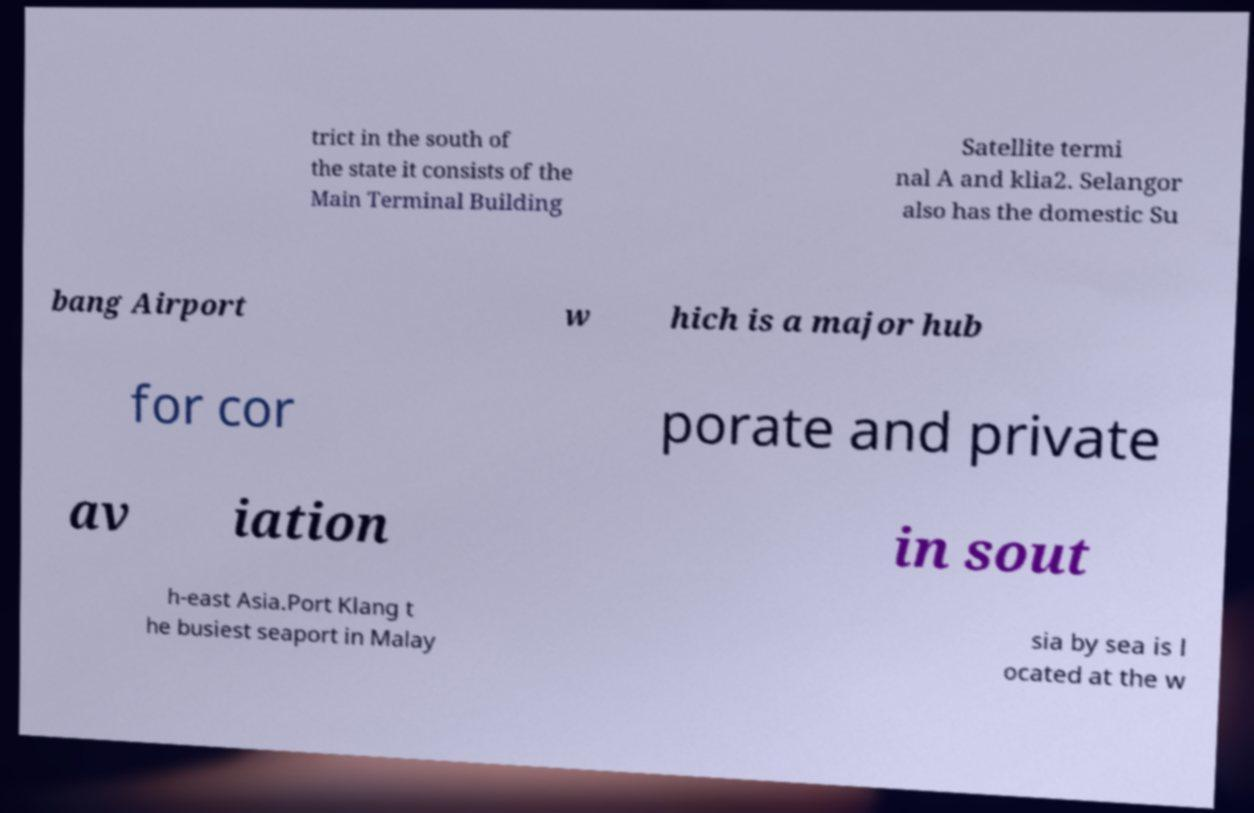Please read and relay the text visible in this image. What does it say? trict in the south of the state it consists of the Main Terminal Building Satellite termi nal A and klia2. Selangor also has the domestic Su bang Airport w hich is a major hub for cor porate and private av iation in sout h-east Asia.Port Klang t he busiest seaport in Malay sia by sea is l ocated at the w 